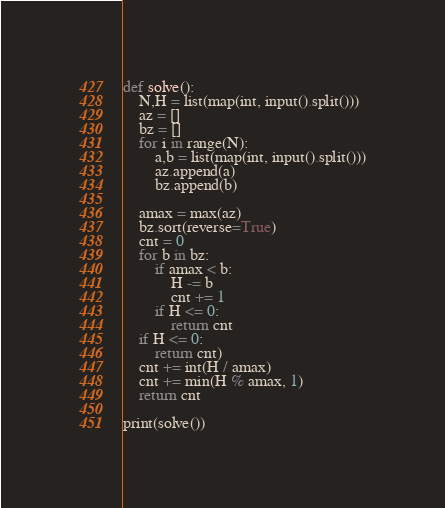Convert code to text. <code><loc_0><loc_0><loc_500><loc_500><_Python_>def solve():
    N,H = list(map(int, input().split()))
    az = []
    bz = []
    for i in range(N):
        a,b = list(map(int, input().split()))
        az.append(a)
        bz.append(b)
        
    amax = max(az)
    bz.sort(reverse=True)
    cnt = 0
    for b in bz:
        if amax < b:
            H -= b
            cnt += 1
        if H <= 0:
            return cnt
    if H <= 0:
        return cnt)
    cnt += int(H / amax)
    cnt += min(H % amax, 1)
    return cnt
        
print(solve())</code> 